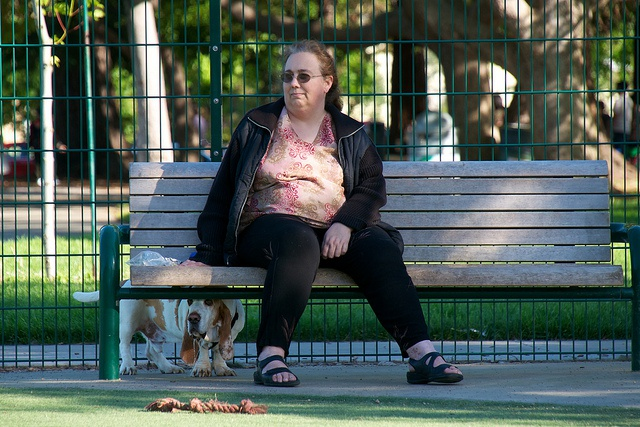Describe the objects in this image and their specific colors. I can see bench in black, gray, and darkgray tones, people in black, gray, lightpink, and darkgray tones, dog in black and gray tones, people in black, gray, darkgray, and darkgreen tones, and people in black, maroon, brown, and blue tones in this image. 